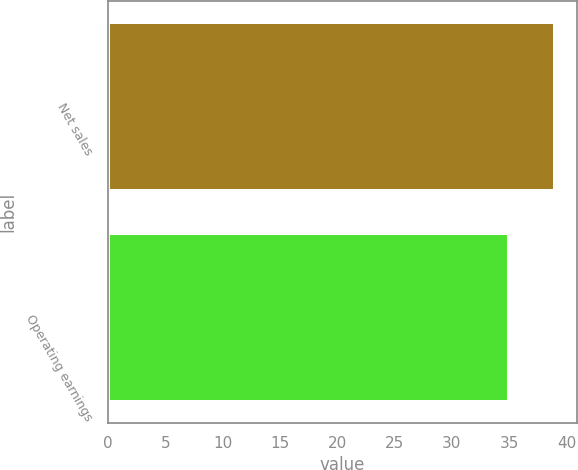Convert chart to OTSL. <chart><loc_0><loc_0><loc_500><loc_500><bar_chart><fcel>Net sales<fcel>Operating earnings<nl><fcel>39<fcel>35<nl></chart> 